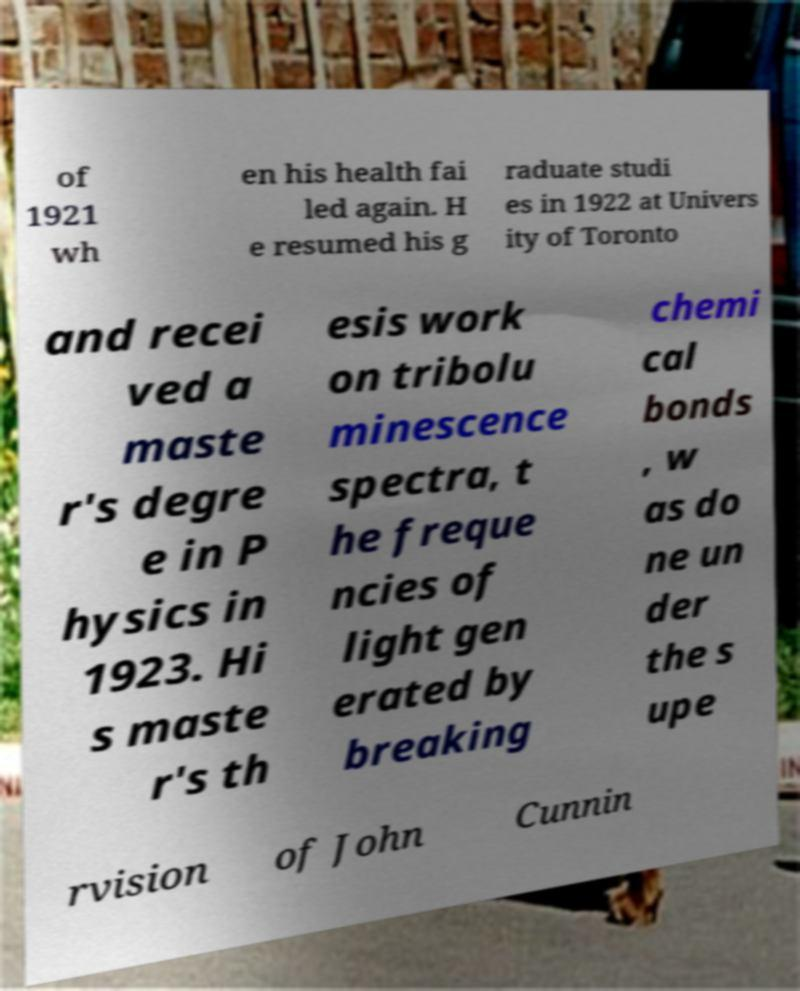Can you read and provide the text displayed in the image?This photo seems to have some interesting text. Can you extract and type it out for me? of 1921 wh en his health fai led again. H e resumed his g raduate studi es in 1922 at Univers ity of Toronto and recei ved a maste r's degre e in P hysics in 1923. Hi s maste r's th esis work on tribolu minescence spectra, t he freque ncies of light gen erated by breaking chemi cal bonds , w as do ne un der the s upe rvision of John Cunnin 